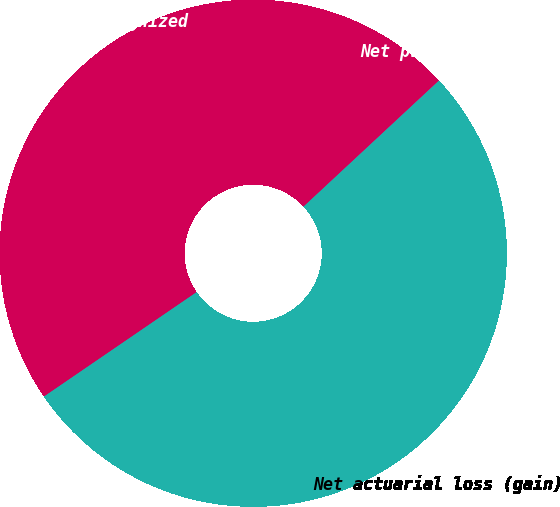<chart> <loc_0><loc_0><loc_500><loc_500><pie_chart><fcel>Net actuarial loss (gain)<fcel>Net prior service cost<fcel>Total not yet recognized<nl><fcel>52.38%<fcel>0.01%<fcel>47.62%<nl></chart> 